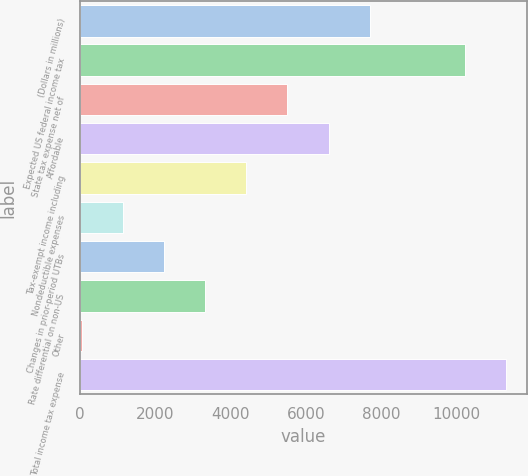Convert chart to OTSL. <chart><loc_0><loc_0><loc_500><loc_500><bar_chart><fcel>(Dollars in millions)<fcel>Expected US federal income tax<fcel>State tax expense net of<fcel>Affordable<fcel>Tax-exempt income including<fcel>Nondeductible expenses<fcel>Changes in prior-period UTBs<fcel>Rate differential on non-US<fcel>Other<fcel>Total income tax expense<nl><fcel>7701.7<fcel>10225<fcel>5515.5<fcel>6608.6<fcel>4422.4<fcel>1143.1<fcel>2236.2<fcel>3329.3<fcel>50<fcel>11318.1<nl></chart> 